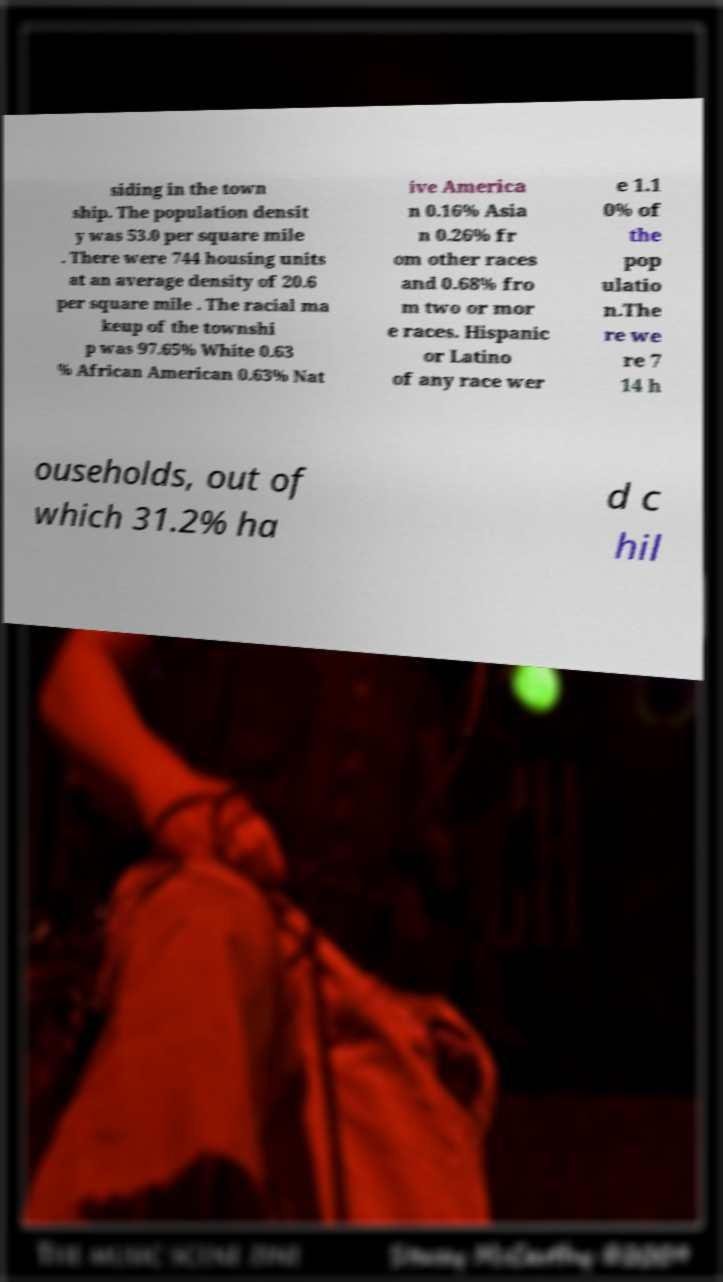Can you read and provide the text displayed in the image?This photo seems to have some interesting text. Can you extract and type it out for me? siding in the town ship. The population densit y was 53.0 per square mile . There were 744 housing units at an average density of 20.6 per square mile . The racial ma keup of the townshi p was 97.65% White 0.63 % African American 0.63% Nat ive America n 0.16% Asia n 0.26% fr om other races and 0.68% fro m two or mor e races. Hispanic or Latino of any race wer e 1.1 0% of the pop ulatio n.The re we re 7 14 h ouseholds, out of which 31.2% ha d c hil 